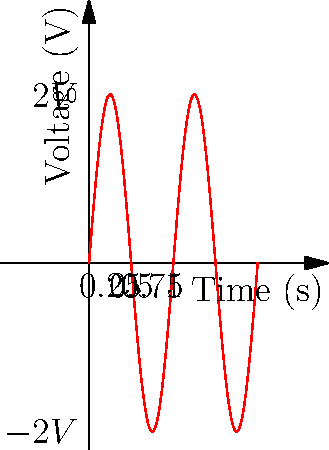As a sponsor of local Spartans events, you're reviewing an electrical engineering project that involves signal analysis. The graph above shows a voltage waveform. What is the frequency of this signal in Hz? To determine the frequency of the signal, we need to follow these steps:

1. Identify the period (T) of the waveform:
   The period is the time it takes for one complete cycle of the wave.
   From the graph, we can see that one complete cycle occurs in 0.5 seconds.
   Therefore, T = 0.5 s

2. Calculate the frequency (f) using the formula:
   $f = \frac{1}{T}$

3. Substitute the value of T:
   $f = \frac{1}{0.5 \text{ s}}$

4. Simplify:
   $f = 2 \text{ Hz}$

The frequency of the signal is 2 Hz, which means it completes 2 cycles per second.
Answer: 2 Hz 